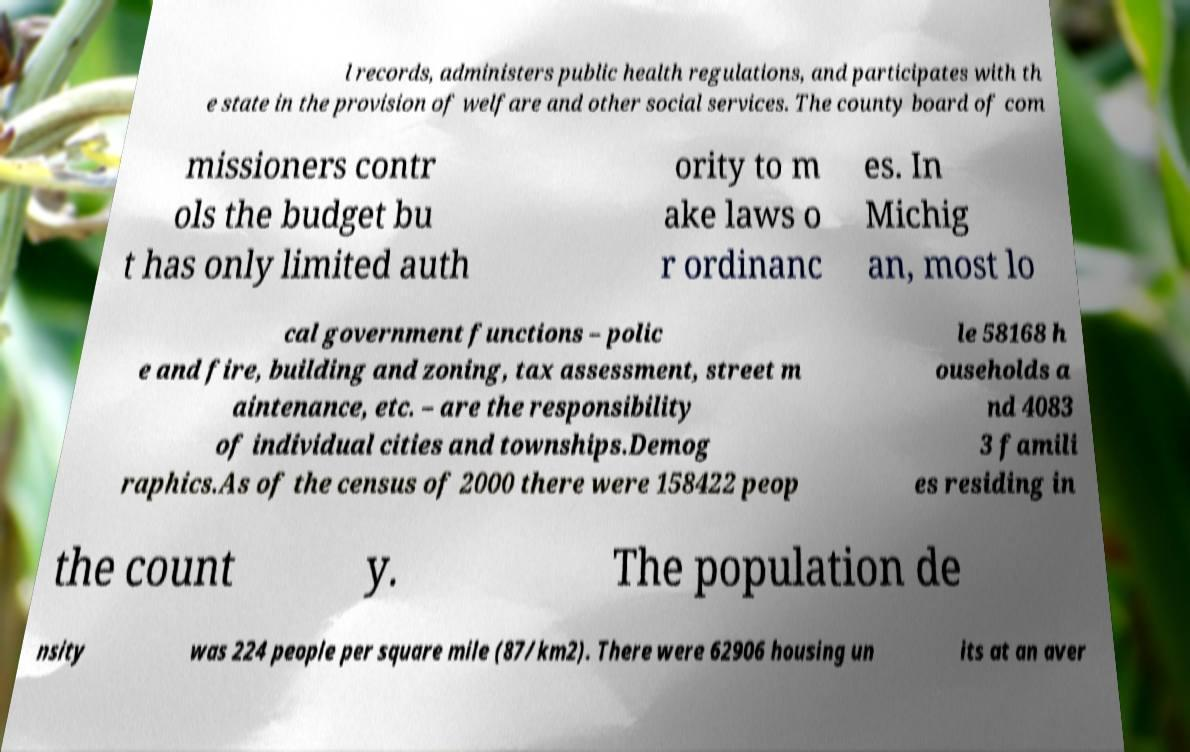Could you extract and type out the text from this image? l records, administers public health regulations, and participates with th e state in the provision of welfare and other social services. The county board of com missioners contr ols the budget bu t has only limited auth ority to m ake laws o r ordinanc es. In Michig an, most lo cal government functions – polic e and fire, building and zoning, tax assessment, street m aintenance, etc. – are the responsibility of individual cities and townships.Demog raphics.As of the census of 2000 there were 158422 peop le 58168 h ouseholds a nd 4083 3 famili es residing in the count y. The population de nsity was 224 people per square mile (87/km2). There were 62906 housing un its at an aver 